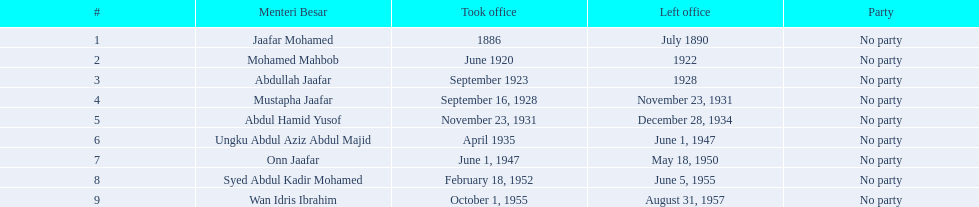Who were all of the menteri besars? Jaafar Mohamed, Mohamed Mahbob, Abdullah Jaafar, Mustapha Jaafar, Abdul Hamid Yusof, Ungku Abdul Aziz Abdul Majid, Onn Jaafar, Syed Abdul Kadir Mohamed, Wan Idris Ibrahim. When did they take office? 1886, June 1920, September 1923, September 16, 1928, November 23, 1931, April 1935, June 1, 1947, February 18, 1952, October 1, 1955. And when did they leave? July 1890, 1922, 1928, November 23, 1931, December 28, 1934, June 1, 1947, May 18, 1950, June 5, 1955, August 31, 1957. Now, who was in office for less than four years? Mohamed Mahbob. 